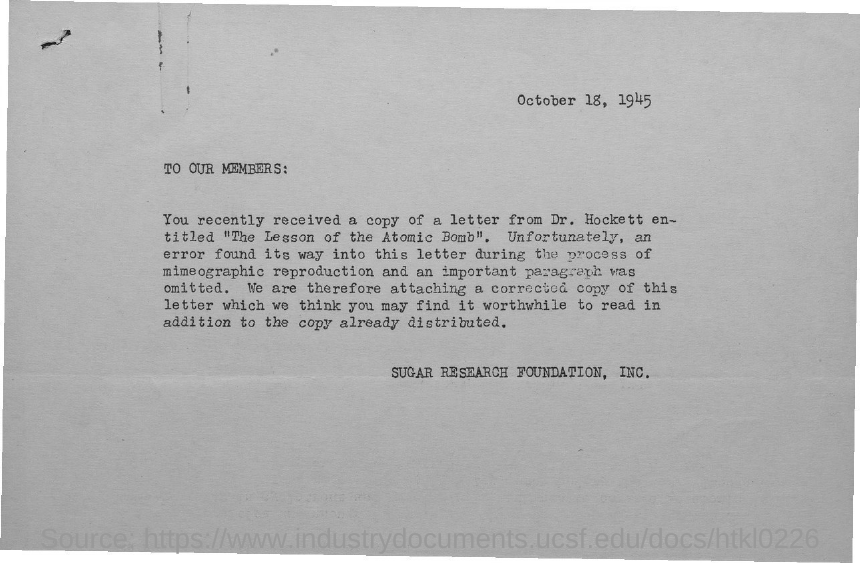Identify some key points in this picture. The document is sent by the Sugar Research Foundation, Inc. The document contains the date of October 18, 1945. 